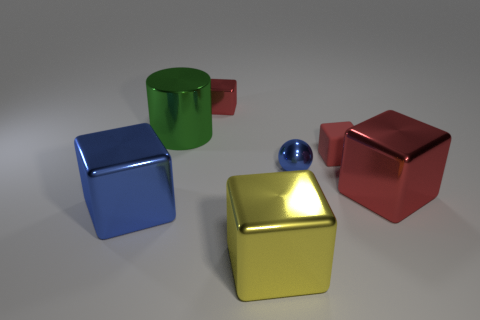Is the number of metal objects in front of the sphere the same as the number of metal cubes that are in front of the big green cylinder?
Give a very brief answer. Yes. What is the color of the small rubber object that is the same shape as the large blue metallic object?
Provide a succinct answer. Red. Is there any other thing that has the same shape as the tiny blue metal object?
Your response must be concise. No. Is the color of the cube that is behind the small matte object the same as the small rubber thing?
Your response must be concise. Yes. What is the size of the blue thing that is the same shape as the yellow thing?
Offer a terse response. Large. What number of big green objects have the same material as the large green cylinder?
Make the answer very short. 0. There is a big metal object in front of the large thing that is on the left side of the green metallic object; are there any big cubes that are left of it?
Keep it short and to the point. Yes. What is the shape of the rubber object?
Provide a short and direct response. Cube. Is the cube that is in front of the large blue thing made of the same material as the tiny red object that is in front of the green shiny object?
Offer a terse response. No. How many small things are the same color as the tiny rubber cube?
Your answer should be very brief. 1. 